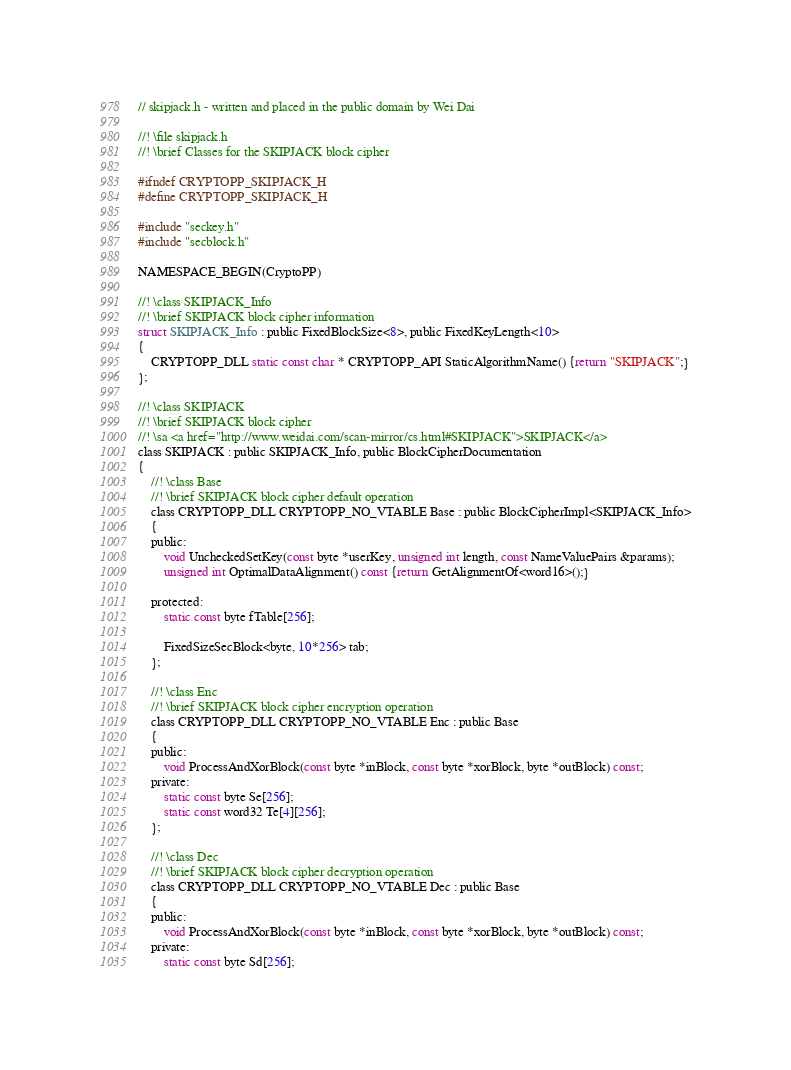<code> <loc_0><loc_0><loc_500><loc_500><_C_>// skipjack.h - written and placed in the public domain by Wei Dai

//! \file skipjack.h
//! \brief Classes for the SKIPJACK block cipher

#ifndef CRYPTOPP_SKIPJACK_H
#define CRYPTOPP_SKIPJACK_H

#include "seckey.h"
#include "secblock.h"

NAMESPACE_BEGIN(CryptoPP)

//! \class SKIPJACK_Info
//! \brief SKIPJACK block cipher information
struct SKIPJACK_Info : public FixedBlockSize<8>, public FixedKeyLength<10>
{
	CRYPTOPP_DLL static const char * CRYPTOPP_API StaticAlgorithmName() {return "SKIPJACK";}
};

//! \class SKIPJACK
//! \brief SKIPJACK block cipher
//! \sa <a href="http://www.weidai.com/scan-mirror/cs.html#SKIPJACK">SKIPJACK</a>
class SKIPJACK : public SKIPJACK_Info, public BlockCipherDocumentation
{
	//! \class Base
	//! \brief SKIPJACK block cipher default operation
	class CRYPTOPP_DLL CRYPTOPP_NO_VTABLE Base : public BlockCipherImpl<SKIPJACK_Info>
	{
	public:
		void UncheckedSetKey(const byte *userKey, unsigned int length, const NameValuePairs &params);
		unsigned int OptimalDataAlignment() const {return GetAlignmentOf<word16>();}

	protected:
		static const byte fTable[256];

		FixedSizeSecBlock<byte, 10*256> tab;
	};

	//! \class Enc
	//! \brief SKIPJACK block cipher encryption operation
	class CRYPTOPP_DLL CRYPTOPP_NO_VTABLE Enc : public Base
	{
	public:
		void ProcessAndXorBlock(const byte *inBlock, const byte *xorBlock, byte *outBlock) const;
	private:
		static const byte Se[256];
		static const word32 Te[4][256];
	};

	//! \class Dec
	//! \brief SKIPJACK block cipher decryption operation
	class CRYPTOPP_DLL CRYPTOPP_NO_VTABLE Dec : public Base
	{
	public:
		void ProcessAndXorBlock(const byte *inBlock, const byte *xorBlock, byte *outBlock) const;
	private:
		static const byte Sd[256];</code> 